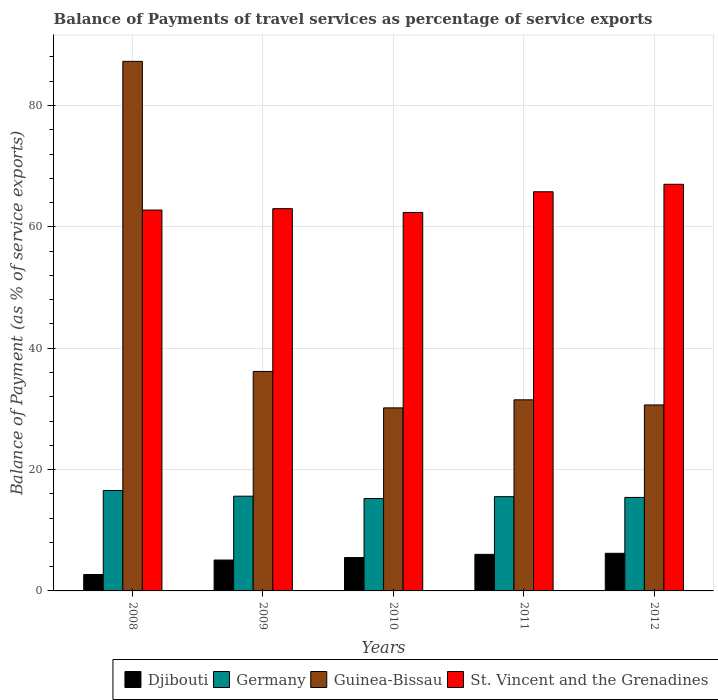How many different coloured bars are there?
Provide a succinct answer. 4. How many groups of bars are there?
Offer a very short reply. 5. Are the number of bars per tick equal to the number of legend labels?
Your answer should be very brief. Yes. What is the label of the 4th group of bars from the left?
Your answer should be very brief. 2011. What is the balance of payments of travel services in Djibouti in 2012?
Provide a succinct answer. 6.2. Across all years, what is the maximum balance of payments of travel services in St. Vincent and the Grenadines?
Make the answer very short. 67.01. Across all years, what is the minimum balance of payments of travel services in Guinea-Bissau?
Offer a terse response. 30.17. In which year was the balance of payments of travel services in St. Vincent and the Grenadines maximum?
Offer a terse response. 2012. In which year was the balance of payments of travel services in St. Vincent and the Grenadines minimum?
Ensure brevity in your answer.  2010. What is the total balance of payments of travel services in Guinea-Bissau in the graph?
Make the answer very short. 215.75. What is the difference between the balance of payments of travel services in Guinea-Bissau in 2009 and that in 2012?
Offer a terse response. 5.52. What is the difference between the balance of payments of travel services in Djibouti in 2008 and the balance of payments of travel services in Guinea-Bissau in 2010?
Provide a succinct answer. -27.46. What is the average balance of payments of travel services in St. Vincent and the Grenadines per year?
Provide a short and direct response. 64.19. In the year 2012, what is the difference between the balance of payments of travel services in Djibouti and balance of payments of travel services in Guinea-Bissau?
Ensure brevity in your answer.  -24.45. In how many years, is the balance of payments of travel services in Djibouti greater than 60 %?
Offer a very short reply. 0. What is the ratio of the balance of payments of travel services in Germany in 2008 to that in 2009?
Keep it short and to the point. 1.06. Is the balance of payments of travel services in St. Vincent and the Grenadines in 2011 less than that in 2012?
Your answer should be very brief. Yes. Is the difference between the balance of payments of travel services in Djibouti in 2009 and 2010 greater than the difference between the balance of payments of travel services in Guinea-Bissau in 2009 and 2010?
Give a very brief answer. No. What is the difference between the highest and the second highest balance of payments of travel services in Germany?
Offer a very short reply. 0.94. What is the difference between the highest and the lowest balance of payments of travel services in Djibouti?
Your answer should be compact. 3.5. In how many years, is the balance of payments of travel services in St. Vincent and the Grenadines greater than the average balance of payments of travel services in St. Vincent and the Grenadines taken over all years?
Keep it short and to the point. 2. Is it the case that in every year, the sum of the balance of payments of travel services in Guinea-Bissau and balance of payments of travel services in Germany is greater than the sum of balance of payments of travel services in St. Vincent and the Grenadines and balance of payments of travel services in Djibouti?
Give a very brief answer. No. What does the 2nd bar from the left in 2008 represents?
Give a very brief answer. Germany. What does the 2nd bar from the right in 2009 represents?
Your answer should be very brief. Guinea-Bissau. Is it the case that in every year, the sum of the balance of payments of travel services in Guinea-Bissau and balance of payments of travel services in Germany is greater than the balance of payments of travel services in Djibouti?
Make the answer very short. Yes. How many bars are there?
Ensure brevity in your answer.  20. Are all the bars in the graph horizontal?
Your response must be concise. No. What is the difference between two consecutive major ticks on the Y-axis?
Provide a short and direct response. 20. Does the graph contain any zero values?
Your answer should be very brief. No. Does the graph contain grids?
Make the answer very short. Yes. Where does the legend appear in the graph?
Your answer should be very brief. Bottom right. What is the title of the graph?
Make the answer very short. Balance of Payments of travel services as percentage of service exports. What is the label or title of the Y-axis?
Make the answer very short. Balance of Payment (as % of service exports). What is the Balance of Payment (as % of service exports) in Djibouti in 2008?
Provide a succinct answer. 2.71. What is the Balance of Payment (as % of service exports) in Germany in 2008?
Keep it short and to the point. 16.55. What is the Balance of Payment (as % of service exports) of Guinea-Bissau in 2008?
Provide a succinct answer. 87.27. What is the Balance of Payment (as % of service exports) in St. Vincent and the Grenadines in 2008?
Offer a very short reply. 62.77. What is the Balance of Payment (as % of service exports) in Djibouti in 2009?
Your answer should be very brief. 5.09. What is the Balance of Payment (as % of service exports) of Germany in 2009?
Provide a short and direct response. 15.61. What is the Balance of Payment (as % of service exports) in Guinea-Bissau in 2009?
Your response must be concise. 36.17. What is the Balance of Payment (as % of service exports) of St. Vincent and the Grenadines in 2009?
Ensure brevity in your answer.  63. What is the Balance of Payment (as % of service exports) of Djibouti in 2010?
Your answer should be compact. 5.5. What is the Balance of Payment (as % of service exports) in Germany in 2010?
Keep it short and to the point. 15.23. What is the Balance of Payment (as % of service exports) in Guinea-Bissau in 2010?
Make the answer very short. 30.17. What is the Balance of Payment (as % of service exports) in St. Vincent and the Grenadines in 2010?
Ensure brevity in your answer.  62.37. What is the Balance of Payment (as % of service exports) in Djibouti in 2011?
Provide a short and direct response. 6.03. What is the Balance of Payment (as % of service exports) of Germany in 2011?
Provide a succinct answer. 15.53. What is the Balance of Payment (as % of service exports) of Guinea-Bissau in 2011?
Your response must be concise. 31.49. What is the Balance of Payment (as % of service exports) in St. Vincent and the Grenadines in 2011?
Provide a short and direct response. 65.78. What is the Balance of Payment (as % of service exports) of Djibouti in 2012?
Give a very brief answer. 6.2. What is the Balance of Payment (as % of service exports) in Germany in 2012?
Make the answer very short. 15.41. What is the Balance of Payment (as % of service exports) of Guinea-Bissau in 2012?
Offer a terse response. 30.65. What is the Balance of Payment (as % of service exports) of St. Vincent and the Grenadines in 2012?
Your answer should be very brief. 67.01. Across all years, what is the maximum Balance of Payment (as % of service exports) in Djibouti?
Provide a short and direct response. 6.2. Across all years, what is the maximum Balance of Payment (as % of service exports) in Germany?
Provide a short and direct response. 16.55. Across all years, what is the maximum Balance of Payment (as % of service exports) in Guinea-Bissau?
Keep it short and to the point. 87.27. Across all years, what is the maximum Balance of Payment (as % of service exports) in St. Vincent and the Grenadines?
Offer a very short reply. 67.01. Across all years, what is the minimum Balance of Payment (as % of service exports) in Djibouti?
Provide a short and direct response. 2.71. Across all years, what is the minimum Balance of Payment (as % of service exports) in Germany?
Offer a very short reply. 15.23. Across all years, what is the minimum Balance of Payment (as % of service exports) in Guinea-Bissau?
Give a very brief answer. 30.17. Across all years, what is the minimum Balance of Payment (as % of service exports) of St. Vincent and the Grenadines?
Ensure brevity in your answer.  62.37. What is the total Balance of Payment (as % of service exports) of Djibouti in the graph?
Provide a short and direct response. 25.53. What is the total Balance of Payment (as % of service exports) in Germany in the graph?
Ensure brevity in your answer.  78.33. What is the total Balance of Payment (as % of service exports) of Guinea-Bissau in the graph?
Keep it short and to the point. 215.75. What is the total Balance of Payment (as % of service exports) of St. Vincent and the Grenadines in the graph?
Keep it short and to the point. 320.94. What is the difference between the Balance of Payment (as % of service exports) in Djibouti in 2008 and that in 2009?
Give a very brief answer. -2.38. What is the difference between the Balance of Payment (as % of service exports) in Germany in 2008 and that in 2009?
Make the answer very short. 0.94. What is the difference between the Balance of Payment (as % of service exports) in Guinea-Bissau in 2008 and that in 2009?
Your answer should be very brief. 51.1. What is the difference between the Balance of Payment (as % of service exports) in St. Vincent and the Grenadines in 2008 and that in 2009?
Your answer should be compact. -0.22. What is the difference between the Balance of Payment (as % of service exports) in Djibouti in 2008 and that in 2010?
Keep it short and to the point. -2.79. What is the difference between the Balance of Payment (as % of service exports) of Germany in 2008 and that in 2010?
Keep it short and to the point. 1.32. What is the difference between the Balance of Payment (as % of service exports) of Guinea-Bissau in 2008 and that in 2010?
Offer a very short reply. 57.11. What is the difference between the Balance of Payment (as % of service exports) of St. Vincent and the Grenadines in 2008 and that in 2010?
Your response must be concise. 0.4. What is the difference between the Balance of Payment (as % of service exports) in Djibouti in 2008 and that in 2011?
Your response must be concise. -3.32. What is the difference between the Balance of Payment (as % of service exports) of Germany in 2008 and that in 2011?
Offer a very short reply. 1.01. What is the difference between the Balance of Payment (as % of service exports) of Guinea-Bissau in 2008 and that in 2011?
Your answer should be compact. 55.78. What is the difference between the Balance of Payment (as % of service exports) of St. Vincent and the Grenadines in 2008 and that in 2011?
Provide a succinct answer. -3.01. What is the difference between the Balance of Payment (as % of service exports) in Djibouti in 2008 and that in 2012?
Your response must be concise. -3.5. What is the difference between the Balance of Payment (as % of service exports) of Germany in 2008 and that in 2012?
Offer a terse response. 1.14. What is the difference between the Balance of Payment (as % of service exports) in Guinea-Bissau in 2008 and that in 2012?
Ensure brevity in your answer.  56.63. What is the difference between the Balance of Payment (as % of service exports) of St. Vincent and the Grenadines in 2008 and that in 2012?
Offer a terse response. -4.24. What is the difference between the Balance of Payment (as % of service exports) of Djibouti in 2009 and that in 2010?
Make the answer very short. -0.41. What is the difference between the Balance of Payment (as % of service exports) of Germany in 2009 and that in 2010?
Offer a very short reply. 0.38. What is the difference between the Balance of Payment (as % of service exports) in Guinea-Bissau in 2009 and that in 2010?
Your answer should be compact. 6.01. What is the difference between the Balance of Payment (as % of service exports) in St. Vincent and the Grenadines in 2009 and that in 2010?
Your response must be concise. 0.63. What is the difference between the Balance of Payment (as % of service exports) in Djibouti in 2009 and that in 2011?
Offer a terse response. -0.94. What is the difference between the Balance of Payment (as % of service exports) in Germany in 2009 and that in 2011?
Your answer should be very brief. 0.08. What is the difference between the Balance of Payment (as % of service exports) in Guinea-Bissau in 2009 and that in 2011?
Provide a short and direct response. 4.68. What is the difference between the Balance of Payment (as % of service exports) in St. Vincent and the Grenadines in 2009 and that in 2011?
Your response must be concise. -2.79. What is the difference between the Balance of Payment (as % of service exports) of Djibouti in 2009 and that in 2012?
Keep it short and to the point. -1.11. What is the difference between the Balance of Payment (as % of service exports) of Germany in 2009 and that in 2012?
Your response must be concise. 0.2. What is the difference between the Balance of Payment (as % of service exports) of Guinea-Bissau in 2009 and that in 2012?
Your answer should be compact. 5.52. What is the difference between the Balance of Payment (as % of service exports) in St. Vincent and the Grenadines in 2009 and that in 2012?
Your response must be concise. -4.02. What is the difference between the Balance of Payment (as % of service exports) of Djibouti in 2010 and that in 2011?
Keep it short and to the point. -0.53. What is the difference between the Balance of Payment (as % of service exports) in Germany in 2010 and that in 2011?
Keep it short and to the point. -0.31. What is the difference between the Balance of Payment (as % of service exports) of Guinea-Bissau in 2010 and that in 2011?
Your answer should be very brief. -1.33. What is the difference between the Balance of Payment (as % of service exports) of St. Vincent and the Grenadines in 2010 and that in 2011?
Make the answer very short. -3.42. What is the difference between the Balance of Payment (as % of service exports) in Djibouti in 2010 and that in 2012?
Provide a short and direct response. -0.7. What is the difference between the Balance of Payment (as % of service exports) in Germany in 2010 and that in 2012?
Your answer should be very brief. -0.18. What is the difference between the Balance of Payment (as % of service exports) in Guinea-Bissau in 2010 and that in 2012?
Ensure brevity in your answer.  -0.48. What is the difference between the Balance of Payment (as % of service exports) of St. Vincent and the Grenadines in 2010 and that in 2012?
Make the answer very short. -4.65. What is the difference between the Balance of Payment (as % of service exports) of Djibouti in 2011 and that in 2012?
Provide a succinct answer. -0.17. What is the difference between the Balance of Payment (as % of service exports) of Germany in 2011 and that in 2012?
Provide a short and direct response. 0.13. What is the difference between the Balance of Payment (as % of service exports) of Guinea-Bissau in 2011 and that in 2012?
Provide a short and direct response. 0.85. What is the difference between the Balance of Payment (as % of service exports) of St. Vincent and the Grenadines in 2011 and that in 2012?
Offer a very short reply. -1.23. What is the difference between the Balance of Payment (as % of service exports) of Djibouti in 2008 and the Balance of Payment (as % of service exports) of Germany in 2009?
Offer a terse response. -12.9. What is the difference between the Balance of Payment (as % of service exports) of Djibouti in 2008 and the Balance of Payment (as % of service exports) of Guinea-Bissau in 2009?
Offer a terse response. -33.46. What is the difference between the Balance of Payment (as % of service exports) in Djibouti in 2008 and the Balance of Payment (as % of service exports) in St. Vincent and the Grenadines in 2009?
Your answer should be very brief. -60.29. What is the difference between the Balance of Payment (as % of service exports) in Germany in 2008 and the Balance of Payment (as % of service exports) in Guinea-Bissau in 2009?
Your response must be concise. -19.62. What is the difference between the Balance of Payment (as % of service exports) in Germany in 2008 and the Balance of Payment (as % of service exports) in St. Vincent and the Grenadines in 2009?
Make the answer very short. -46.45. What is the difference between the Balance of Payment (as % of service exports) of Guinea-Bissau in 2008 and the Balance of Payment (as % of service exports) of St. Vincent and the Grenadines in 2009?
Offer a very short reply. 24.28. What is the difference between the Balance of Payment (as % of service exports) in Djibouti in 2008 and the Balance of Payment (as % of service exports) in Germany in 2010?
Your answer should be very brief. -12.52. What is the difference between the Balance of Payment (as % of service exports) of Djibouti in 2008 and the Balance of Payment (as % of service exports) of Guinea-Bissau in 2010?
Your response must be concise. -27.46. What is the difference between the Balance of Payment (as % of service exports) of Djibouti in 2008 and the Balance of Payment (as % of service exports) of St. Vincent and the Grenadines in 2010?
Make the answer very short. -59.66. What is the difference between the Balance of Payment (as % of service exports) of Germany in 2008 and the Balance of Payment (as % of service exports) of Guinea-Bissau in 2010?
Keep it short and to the point. -13.62. What is the difference between the Balance of Payment (as % of service exports) in Germany in 2008 and the Balance of Payment (as % of service exports) in St. Vincent and the Grenadines in 2010?
Make the answer very short. -45.82. What is the difference between the Balance of Payment (as % of service exports) in Guinea-Bissau in 2008 and the Balance of Payment (as % of service exports) in St. Vincent and the Grenadines in 2010?
Provide a succinct answer. 24.91. What is the difference between the Balance of Payment (as % of service exports) of Djibouti in 2008 and the Balance of Payment (as % of service exports) of Germany in 2011?
Offer a terse response. -12.83. What is the difference between the Balance of Payment (as % of service exports) of Djibouti in 2008 and the Balance of Payment (as % of service exports) of Guinea-Bissau in 2011?
Your answer should be very brief. -28.79. What is the difference between the Balance of Payment (as % of service exports) in Djibouti in 2008 and the Balance of Payment (as % of service exports) in St. Vincent and the Grenadines in 2011?
Offer a terse response. -63.08. What is the difference between the Balance of Payment (as % of service exports) of Germany in 2008 and the Balance of Payment (as % of service exports) of Guinea-Bissau in 2011?
Make the answer very short. -14.94. What is the difference between the Balance of Payment (as % of service exports) of Germany in 2008 and the Balance of Payment (as % of service exports) of St. Vincent and the Grenadines in 2011?
Your answer should be compact. -49.24. What is the difference between the Balance of Payment (as % of service exports) in Guinea-Bissau in 2008 and the Balance of Payment (as % of service exports) in St. Vincent and the Grenadines in 2011?
Give a very brief answer. 21.49. What is the difference between the Balance of Payment (as % of service exports) of Djibouti in 2008 and the Balance of Payment (as % of service exports) of Germany in 2012?
Your answer should be compact. -12.7. What is the difference between the Balance of Payment (as % of service exports) in Djibouti in 2008 and the Balance of Payment (as % of service exports) in Guinea-Bissau in 2012?
Make the answer very short. -27.94. What is the difference between the Balance of Payment (as % of service exports) in Djibouti in 2008 and the Balance of Payment (as % of service exports) in St. Vincent and the Grenadines in 2012?
Provide a succinct answer. -64.31. What is the difference between the Balance of Payment (as % of service exports) of Germany in 2008 and the Balance of Payment (as % of service exports) of Guinea-Bissau in 2012?
Make the answer very short. -14.1. What is the difference between the Balance of Payment (as % of service exports) of Germany in 2008 and the Balance of Payment (as % of service exports) of St. Vincent and the Grenadines in 2012?
Give a very brief answer. -50.47. What is the difference between the Balance of Payment (as % of service exports) in Guinea-Bissau in 2008 and the Balance of Payment (as % of service exports) in St. Vincent and the Grenadines in 2012?
Make the answer very short. 20.26. What is the difference between the Balance of Payment (as % of service exports) in Djibouti in 2009 and the Balance of Payment (as % of service exports) in Germany in 2010?
Offer a terse response. -10.14. What is the difference between the Balance of Payment (as % of service exports) in Djibouti in 2009 and the Balance of Payment (as % of service exports) in Guinea-Bissau in 2010?
Your answer should be very brief. -25.08. What is the difference between the Balance of Payment (as % of service exports) in Djibouti in 2009 and the Balance of Payment (as % of service exports) in St. Vincent and the Grenadines in 2010?
Ensure brevity in your answer.  -57.28. What is the difference between the Balance of Payment (as % of service exports) of Germany in 2009 and the Balance of Payment (as % of service exports) of Guinea-Bissau in 2010?
Give a very brief answer. -14.56. What is the difference between the Balance of Payment (as % of service exports) of Germany in 2009 and the Balance of Payment (as % of service exports) of St. Vincent and the Grenadines in 2010?
Make the answer very short. -46.76. What is the difference between the Balance of Payment (as % of service exports) in Guinea-Bissau in 2009 and the Balance of Payment (as % of service exports) in St. Vincent and the Grenadines in 2010?
Your response must be concise. -26.2. What is the difference between the Balance of Payment (as % of service exports) in Djibouti in 2009 and the Balance of Payment (as % of service exports) in Germany in 2011?
Ensure brevity in your answer.  -10.45. What is the difference between the Balance of Payment (as % of service exports) in Djibouti in 2009 and the Balance of Payment (as % of service exports) in Guinea-Bissau in 2011?
Your response must be concise. -26.4. What is the difference between the Balance of Payment (as % of service exports) of Djibouti in 2009 and the Balance of Payment (as % of service exports) of St. Vincent and the Grenadines in 2011?
Your response must be concise. -60.7. What is the difference between the Balance of Payment (as % of service exports) of Germany in 2009 and the Balance of Payment (as % of service exports) of Guinea-Bissau in 2011?
Provide a short and direct response. -15.88. What is the difference between the Balance of Payment (as % of service exports) in Germany in 2009 and the Balance of Payment (as % of service exports) in St. Vincent and the Grenadines in 2011?
Give a very brief answer. -50.17. What is the difference between the Balance of Payment (as % of service exports) of Guinea-Bissau in 2009 and the Balance of Payment (as % of service exports) of St. Vincent and the Grenadines in 2011?
Offer a terse response. -29.61. What is the difference between the Balance of Payment (as % of service exports) in Djibouti in 2009 and the Balance of Payment (as % of service exports) in Germany in 2012?
Your response must be concise. -10.32. What is the difference between the Balance of Payment (as % of service exports) in Djibouti in 2009 and the Balance of Payment (as % of service exports) in Guinea-Bissau in 2012?
Provide a succinct answer. -25.56. What is the difference between the Balance of Payment (as % of service exports) of Djibouti in 2009 and the Balance of Payment (as % of service exports) of St. Vincent and the Grenadines in 2012?
Ensure brevity in your answer.  -61.93. What is the difference between the Balance of Payment (as % of service exports) in Germany in 2009 and the Balance of Payment (as % of service exports) in Guinea-Bissau in 2012?
Your response must be concise. -15.04. What is the difference between the Balance of Payment (as % of service exports) of Germany in 2009 and the Balance of Payment (as % of service exports) of St. Vincent and the Grenadines in 2012?
Give a very brief answer. -51.4. What is the difference between the Balance of Payment (as % of service exports) in Guinea-Bissau in 2009 and the Balance of Payment (as % of service exports) in St. Vincent and the Grenadines in 2012?
Ensure brevity in your answer.  -30.84. What is the difference between the Balance of Payment (as % of service exports) of Djibouti in 2010 and the Balance of Payment (as % of service exports) of Germany in 2011?
Your answer should be very brief. -10.03. What is the difference between the Balance of Payment (as % of service exports) of Djibouti in 2010 and the Balance of Payment (as % of service exports) of Guinea-Bissau in 2011?
Offer a very short reply. -25.99. What is the difference between the Balance of Payment (as % of service exports) in Djibouti in 2010 and the Balance of Payment (as % of service exports) in St. Vincent and the Grenadines in 2011?
Keep it short and to the point. -60.28. What is the difference between the Balance of Payment (as % of service exports) in Germany in 2010 and the Balance of Payment (as % of service exports) in Guinea-Bissau in 2011?
Ensure brevity in your answer.  -16.27. What is the difference between the Balance of Payment (as % of service exports) of Germany in 2010 and the Balance of Payment (as % of service exports) of St. Vincent and the Grenadines in 2011?
Your answer should be very brief. -50.56. What is the difference between the Balance of Payment (as % of service exports) in Guinea-Bissau in 2010 and the Balance of Payment (as % of service exports) in St. Vincent and the Grenadines in 2011?
Offer a terse response. -35.62. What is the difference between the Balance of Payment (as % of service exports) in Djibouti in 2010 and the Balance of Payment (as % of service exports) in Germany in 2012?
Your answer should be very brief. -9.91. What is the difference between the Balance of Payment (as % of service exports) in Djibouti in 2010 and the Balance of Payment (as % of service exports) in Guinea-Bissau in 2012?
Your response must be concise. -25.15. What is the difference between the Balance of Payment (as % of service exports) of Djibouti in 2010 and the Balance of Payment (as % of service exports) of St. Vincent and the Grenadines in 2012?
Your answer should be very brief. -61.51. What is the difference between the Balance of Payment (as % of service exports) in Germany in 2010 and the Balance of Payment (as % of service exports) in Guinea-Bissau in 2012?
Keep it short and to the point. -15.42. What is the difference between the Balance of Payment (as % of service exports) of Germany in 2010 and the Balance of Payment (as % of service exports) of St. Vincent and the Grenadines in 2012?
Give a very brief answer. -51.79. What is the difference between the Balance of Payment (as % of service exports) of Guinea-Bissau in 2010 and the Balance of Payment (as % of service exports) of St. Vincent and the Grenadines in 2012?
Your answer should be compact. -36.85. What is the difference between the Balance of Payment (as % of service exports) in Djibouti in 2011 and the Balance of Payment (as % of service exports) in Germany in 2012?
Your answer should be very brief. -9.38. What is the difference between the Balance of Payment (as % of service exports) of Djibouti in 2011 and the Balance of Payment (as % of service exports) of Guinea-Bissau in 2012?
Offer a very short reply. -24.62. What is the difference between the Balance of Payment (as % of service exports) of Djibouti in 2011 and the Balance of Payment (as % of service exports) of St. Vincent and the Grenadines in 2012?
Your response must be concise. -60.98. What is the difference between the Balance of Payment (as % of service exports) of Germany in 2011 and the Balance of Payment (as % of service exports) of Guinea-Bissau in 2012?
Provide a short and direct response. -15.11. What is the difference between the Balance of Payment (as % of service exports) of Germany in 2011 and the Balance of Payment (as % of service exports) of St. Vincent and the Grenadines in 2012?
Your answer should be very brief. -51.48. What is the difference between the Balance of Payment (as % of service exports) in Guinea-Bissau in 2011 and the Balance of Payment (as % of service exports) in St. Vincent and the Grenadines in 2012?
Offer a terse response. -35.52. What is the average Balance of Payment (as % of service exports) of Djibouti per year?
Make the answer very short. 5.11. What is the average Balance of Payment (as % of service exports) of Germany per year?
Provide a succinct answer. 15.67. What is the average Balance of Payment (as % of service exports) of Guinea-Bissau per year?
Ensure brevity in your answer.  43.15. What is the average Balance of Payment (as % of service exports) of St. Vincent and the Grenadines per year?
Your response must be concise. 64.19. In the year 2008, what is the difference between the Balance of Payment (as % of service exports) in Djibouti and Balance of Payment (as % of service exports) in Germany?
Make the answer very short. -13.84. In the year 2008, what is the difference between the Balance of Payment (as % of service exports) in Djibouti and Balance of Payment (as % of service exports) in Guinea-Bissau?
Provide a succinct answer. -84.57. In the year 2008, what is the difference between the Balance of Payment (as % of service exports) of Djibouti and Balance of Payment (as % of service exports) of St. Vincent and the Grenadines?
Offer a very short reply. -60.07. In the year 2008, what is the difference between the Balance of Payment (as % of service exports) of Germany and Balance of Payment (as % of service exports) of Guinea-Bissau?
Offer a very short reply. -70.73. In the year 2008, what is the difference between the Balance of Payment (as % of service exports) in Germany and Balance of Payment (as % of service exports) in St. Vincent and the Grenadines?
Your answer should be very brief. -46.22. In the year 2008, what is the difference between the Balance of Payment (as % of service exports) in Guinea-Bissau and Balance of Payment (as % of service exports) in St. Vincent and the Grenadines?
Your answer should be very brief. 24.5. In the year 2009, what is the difference between the Balance of Payment (as % of service exports) in Djibouti and Balance of Payment (as % of service exports) in Germany?
Your answer should be very brief. -10.52. In the year 2009, what is the difference between the Balance of Payment (as % of service exports) in Djibouti and Balance of Payment (as % of service exports) in Guinea-Bissau?
Offer a very short reply. -31.08. In the year 2009, what is the difference between the Balance of Payment (as % of service exports) of Djibouti and Balance of Payment (as % of service exports) of St. Vincent and the Grenadines?
Make the answer very short. -57.91. In the year 2009, what is the difference between the Balance of Payment (as % of service exports) in Germany and Balance of Payment (as % of service exports) in Guinea-Bissau?
Keep it short and to the point. -20.56. In the year 2009, what is the difference between the Balance of Payment (as % of service exports) in Germany and Balance of Payment (as % of service exports) in St. Vincent and the Grenadines?
Your response must be concise. -47.39. In the year 2009, what is the difference between the Balance of Payment (as % of service exports) of Guinea-Bissau and Balance of Payment (as % of service exports) of St. Vincent and the Grenadines?
Your response must be concise. -26.82. In the year 2010, what is the difference between the Balance of Payment (as % of service exports) of Djibouti and Balance of Payment (as % of service exports) of Germany?
Offer a terse response. -9.72. In the year 2010, what is the difference between the Balance of Payment (as % of service exports) in Djibouti and Balance of Payment (as % of service exports) in Guinea-Bissau?
Provide a succinct answer. -24.66. In the year 2010, what is the difference between the Balance of Payment (as % of service exports) in Djibouti and Balance of Payment (as % of service exports) in St. Vincent and the Grenadines?
Offer a very short reply. -56.87. In the year 2010, what is the difference between the Balance of Payment (as % of service exports) in Germany and Balance of Payment (as % of service exports) in Guinea-Bissau?
Your answer should be very brief. -14.94. In the year 2010, what is the difference between the Balance of Payment (as % of service exports) of Germany and Balance of Payment (as % of service exports) of St. Vincent and the Grenadines?
Provide a short and direct response. -47.14. In the year 2010, what is the difference between the Balance of Payment (as % of service exports) in Guinea-Bissau and Balance of Payment (as % of service exports) in St. Vincent and the Grenadines?
Provide a succinct answer. -32.2. In the year 2011, what is the difference between the Balance of Payment (as % of service exports) of Djibouti and Balance of Payment (as % of service exports) of Germany?
Your answer should be very brief. -9.5. In the year 2011, what is the difference between the Balance of Payment (as % of service exports) in Djibouti and Balance of Payment (as % of service exports) in Guinea-Bissau?
Offer a very short reply. -25.46. In the year 2011, what is the difference between the Balance of Payment (as % of service exports) of Djibouti and Balance of Payment (as % of service exports) of St. Vincent and the Grenadines?
Give a very brief answer. -59.75. In the year 2011, what is the difference between the Balance of Payment (as % of service exports) of Germany and Balance of Payment (as % of service exports) of Guinea-Bissau?
Your answer should be very brief. -15.96. In the year 2011, what is the difference between the Balance of Payment (as % of service exports) of Germany and Balance of Payment (as % of service exports) of St. Vincent and the Grenadines?
Provide a succinct answer. -50.25. In the year 2011, what is the difference between the Balance of Payment (as % of service exports) of Guinea-Bissau and Balance of Payment (as % of service exports) of St. Vincent and the Grenadines?
Your answer should be very brief. -34.29. In the year 2012, what is the difference between the Balance of Payment (as % of service exports) of Djibouti and Balance of Payment (as % of service exports) of Germany?
Offer a very short reply. -9.2. In the year 2012, what is the difference between the Balance of Payment (as % of service exports) of Djibouti and Balance of Payment (as % of service exports) of Guinea-Bissau?
Your answer should be very brief. -24.45. In the year 2012, what is the difference between the Balance of Payment (as % of service exports) of Djibouti and Balance of Payment (as % of service exports) of St. Vincent and the Grenadines?
Keep it short and to the point. -60.81. In the year 2012, what is the difference between the Balance of Payment (as % of service exports) of Germany and Balance of Payment (as % of service exports) of Guinea-Bissau?
Offer a very short reply. -15.24. In the year 2012, what is the difference between the Balance of Payment (as % of service exports) in Germany and Balance of Payment (as % of service exports) in St. Vincent and the Grenadines?
Make the answer very short. -51.61. In the year 2012, what is the difference between the Balance of Payment (as % of service exports) in Guinea-Bissau and Balance of Payment (as % of service exports) in St. Vincent and the Grenadines?
Your response must be concise. -36.37. What is the ratio of the Balance of Payment (as % of service exports) in Djibouti in 2008 to that in 2009?
Offer a terse response. 0.53. What is the ratio of the Balance of Payment (as % of service exports) in Germany in 2008 to that in 2009?
Keep it short and to the point. 1.06. What is the ratio of the Balance of Payment (as % of service exports) of Guinea-Bissau in 2008 to that in 2009?
Make the answer very short. 2.41. What is the ratio of the Balance of Payment (as % of service exports) in St. Vincent and the Grenadines in 2008 to that in 2009?
Offer a very short reply. 1. What is the ratio of the Balance of Payment (as % of service exports) of Djibouti in 2008 to that in 2010?
Offer a terse response. 0.49. What is the ratio of the Balance of Payment (as % of service exports) of Germany in 2008 to that in 2010?
Provide a succinct answer. 1.09. What is the ratio of the Balance of Payment (as % of service exports) of Guinea-Bissau in 2008 to that in 2010?
Ensure brevity in your answer.  2.89. What is the ratio of the Balance of Payment (as % of service exports) of Djibouti in 2008 to that in 2011?
Offer a terse response. 0.45. What is the ratio of the Balance of Payment (as % of service exports) in Germany in 2008 to that in 2011?
Your answer should be very brief. 1.07. What is the ratio of the Balance of Payment (as % of service exports) of Guinea-Bissau in 2008 to that in 2011?
Give a very brief answer. 2.77. What is the ratio of the Balance of Payment (as % of service exports) in St. Vincent and the Grenadines in 2008 to that in 2011?
Offer a very short reply. 0.95. What is the ratio of the Balance of Payment (as % of service exports) in Djibouti in 2008 to that in 2012?
Your answer should be compact. 0.44. What is the ratio of the Balance of Payment (as % of service exports) in Germany in 2008 to that in 2012?
Ensure brevity in your answer.  1.07. What is the ratio of the Balance of Payment (as % of service exports) in Guinea-Bissau in 2008 to that in 2012?
Give a very brief answer. 2.85. What is the ratio of the Balance of Payment (as % of service exports) in St. Vincent and the Grenadines in 2008 to that in 2012?
Your answer should be very brief. 0.94. What is the ratio of the Balance of Payment (as % of service exports) in Djibouti in 2009 to that in 2010?
Your response must be concise. 0.93. What is the ratio of the Balance of Payment (as % of service exports) of Germany in 2009 to that in 2010?
Your answer should be very brief. 1.03. What is the ratio of the Balance of Payment (as % of service exports) in Guinea-Bissau in 2009 to that in 2010?
Keep it short and to the point. 1.2. What is the ratio of the Balance of Payment (as % of service exports) of St. Vincent and the Grenadines in 2009 to that in 2010?
Your answer should be compact. 1.01. What is the ratio of the Balance of Payment (as % of service exports) in Djibouti in 2009 to that in 2011?
Give a very brief answer. 0.84. What is the ratio of the Balance of Payment (as % of service exports) of Germany in 2009 to that in 2011?
Provide a succinct answer. 1. What is the ratio of the Balance of Payment (as % of service exports) in Guinea-Bissau in 2009 to that in 2011?
Your response must be concise. 1.15. What is the ratio of the Balance of Payment (as % of service exports) in St. Vincent and the Grenadines in 2009 to that in 2011?
Your answer should be very brief. 0.96. What is the ratio of the Balance of Payment (as % of service exports) in Djibouti in 2009 to that in 2012?
Your response must be concise. 0.82. What is the ratio of the Balance of Payment (as % of service exports) in Germany in 2009 to that in 2012?
Your answer should be very brief. 1.01. What is the ratio of the Balance of Payment (as % of service exports) in Guinea-Bissau in 2009 to that in 2012?
Your answer should be compact. 1.18. What is the ratio of the Balance of Payment (as % of service exports) in St. Vincent and the Grenadines in 2009 to that in 2012?
Offer a very short reply. 0.94. What is the ratio of the Balance of Payment (as % of service exports) of Djibouti in 2010 to that in 2011?
Your answer should be compact. 0.91. What is the ratio of the Balance of Payment (as % of service exports) of Germany in 2010 to that in 2011?
Offer a very short reply. 0.98. What is the ratio of the Balance of Payment (as % of service exports) in Guinea-Bissau in 2010 to that in 2011?
Your answer should be very brief. 0.96. What is the ratio of the Balance of Payment (as % of service exports) of St. Vincent and the Grenadines in 2010 to that in 2011?
Offer a very short reply. 0.95. What is the ratio of the Balance of Payment (as % of service exports) of Djibouti in 2010 to that in 2012?
Offer a terse response. 0.89. What is the ratio of the Balance of Payment (as % of service exports) of Guinea-Bissau in 2010 to that in 2012?
Ensure brevity in your answer.  0.98. What is the ratio of the Balance of Payment (as % of service exports) in St. Vincent and the Grenadines in 2010 to that in 2012?
Provide a succinct answer. 0.93. What is the ratio of the Balance of Payment (as % of service exports) in Djibouti in 2011 to that in 2012?
Your answer should be very brief. 0.97. What is the ratio of the Balance of Payment (as % of service exports) of Germany in 2011 to that in 2012?
Offer a very short reply. 1.01. What is the ratio of the Balance of Payment (as % of service exports) of Guinea-Bissau in 2011 to that in 2012?
Make the answer very short. 1.03. What is the ratio of the Balance of Payment (as % of service exports) in St. Vincent and the Grenadines in 2011 to that in 2012?
Keep it short and to the point. 0.98. What is the difference between the highest and the second highest Balance of Payment (as % of service exports) in Djibouti?
Keep it short and to the point. 0.17. What is the difference between the highest and the second highest Balance of Payment (as % of service exports) of Germany?
Your response must be concise. 0.94. What is the difference between the highest and the second highest Balance of Payment (as % of service exports) in Guinea-Bissau?
Provide a succinct answer. 51.1. What is the difference between the highest and the second highest Balance of Payment (as % of service exports) in St. Vincent and the Grenadines?
Provide a succinct answer. 1.23. What is the difference between the highest and the lowest Balance of Payment (as % of service exports) of Djibouti?
Offer a very short reply. 3.5. What is the difference between the highest and the lowest Balance of Payment (as % of service exports) in Germany?
Offer a very short reply. 1.32. What is the difference between the highest and the lowest Balance of Payment (as % of service exports) in Guinea-Bissau?
Make the answer very short. 57.11. What is the difference between the highest and the lowest Balance of Payment (as % of service exports) in St. Vincent and the Grenadines?
Your answer should be very brief. 4.65. 